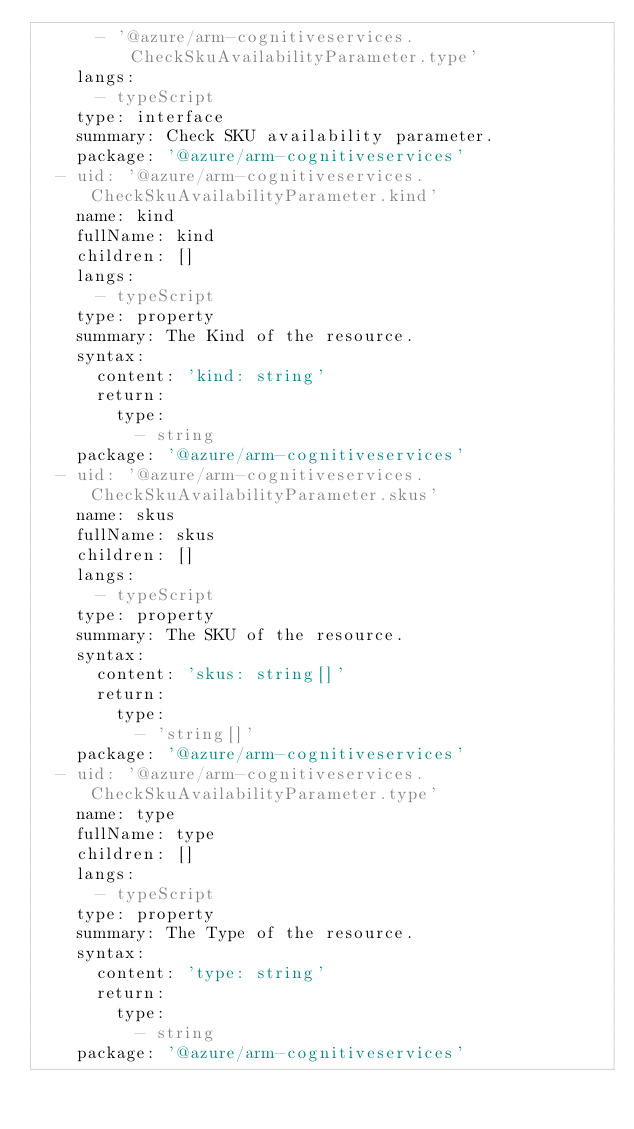Convert code to text. <code><loc_0><loc_0><loc_500><loc_500><_YAML_>      - '@azure/arm-cognitiveservices.CheckSkuAvailabilityParameter.type'
    langs:
      - typeScript
    type: interface
    summary: Check SKU availability parameter.
    package: '@azure/arm-cognitiveservices'
  - uid: '@azure/arm-cognitiveservices.CheckSkuAvailabilityParameter.kind'
    name: kind
    fullName: kind
    children: []
    langs:
      - typeScript
    type: property
    summary: The Kind of the resource.
    syntax:
      content: 'kind: string'
      return:
        type:
          - string
    package: '@azure/arm-cognitiveservices'
  - uid: '@azure/arm-cognitiveservices.CheckSkuAvailabilityParameter.skus'
    name: skus
    fullName: skus
    children: []
    langs:
      - typeScript
    type: property
    summary: The SKU of the resource.
    syntax:
      content: 'skus: string[]'
      return:
        type:
          - 'string[]'
    package: '@azure/arm-cognitiveservices'
  - uid: '@azure/arm-cognitiveservices.CheckSkuAvailabilityParameter.type'
    name: type
    fullName: type
    children: []
    langs:
      - typeScript
    type: property
    summary: The Type of the resource.
    syntax:
      content: 'type: string'
      return:
        type:
          - string
    package: '@azure/arm-cognitiveservices'
</code> 